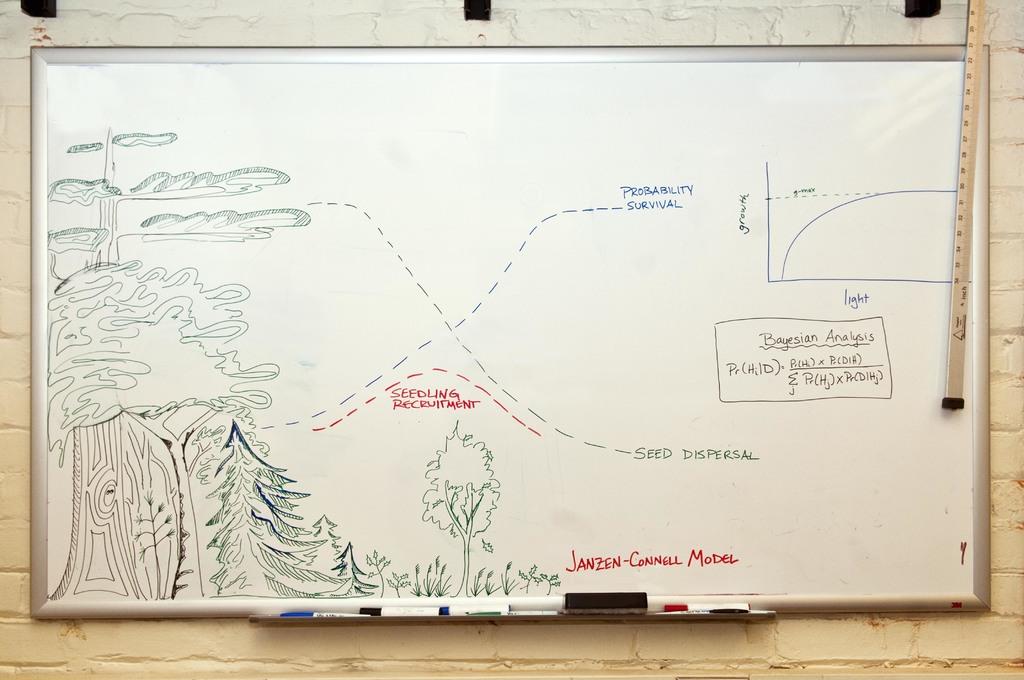What is written on one of the graph's axis?
Your response must be concise. Growth. 